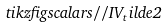<formula> <loc_0><loc_0><loc_500><loc_500>\ t i k z f i g { s c a l a r s / / I V _ { t } i l d e 2 }</formula> 